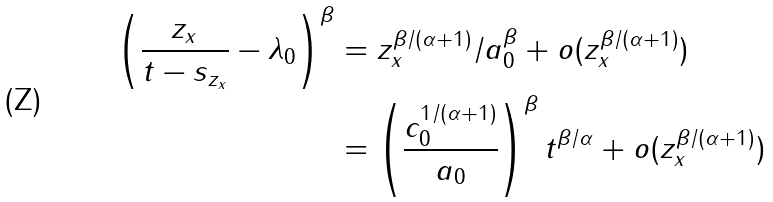Convert formula to latex. <formula><loc_0><loc_0><loc_500><loc_500>\left ( \frac { z _ { x } } { t - s _ { z _ { x } } } - \lambda _ { 0 } \right ) ^ { \beta } & = z _ { x } ^ { \beta / ( \alpha + 1 ) } / a _ { 0 } ^ { \beta } + o ( z _ { x } ^ { \beta / ( \alpha + 1 ) } ) \\ & = \left ( \frac { c _ { 0 } ^ { 1 / ( \alpha + 1 ) } } { a _ { 0 } } \right ) ^ { \beta } t ^ { \beta / \alpha } + o ( z _ { x } ^ { \beta / ( \alpha + 1 ) } )</formula> 